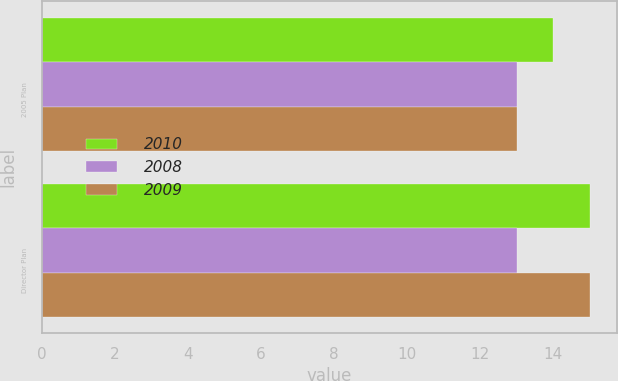Convert chart. <chart><loc_0><loc_0><loc_500><loc_500><stacked_bar_chart><ecel><fcel>2005 Plan<fcel>Director Plan<nl><fcel>2010<fcel>14<fcel>15<nl><fcel>2008<fcel>13<fcel>13<nl><fcel>2009<fcel>13<fcel>15<nl></chart> 